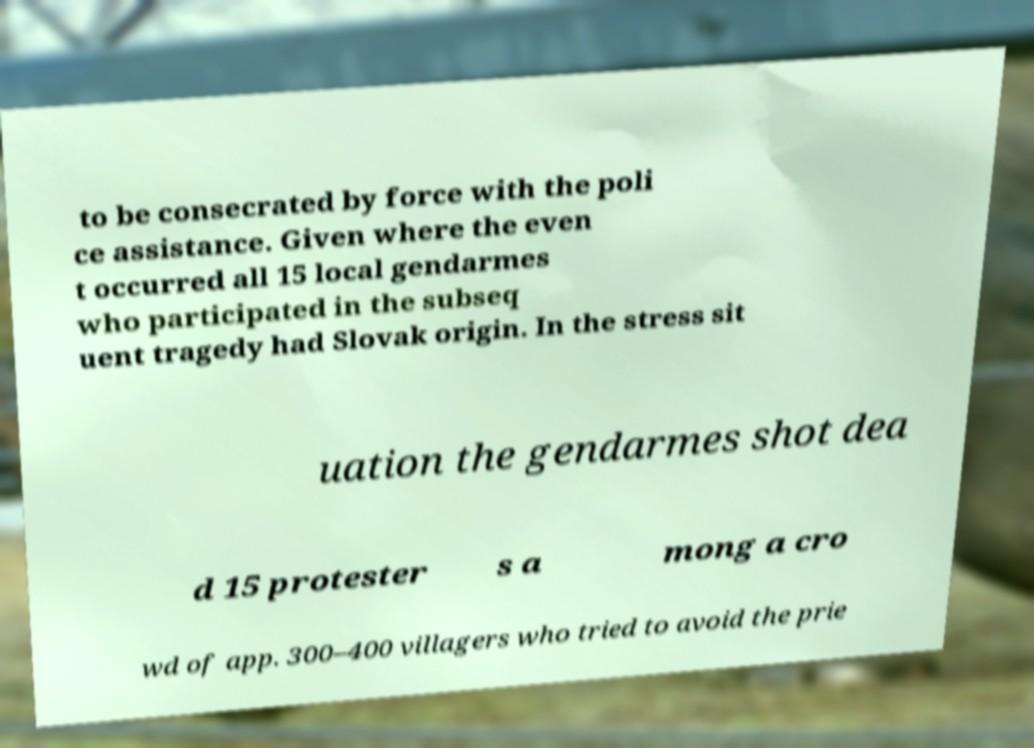There's text embedded in this image that I need extracted. Can you transcribe it verbatim? to be consecrated by force with the poli ce assistance. Given where the even t occurred all 15 local gendarmes who participated in the subseq uent tragedy had Slovak origin. In the stress sit uation the gendarmes shot dea d 15 protester s a mong a cro wd of app. 300–400 villagers who tried to avoid the prie 